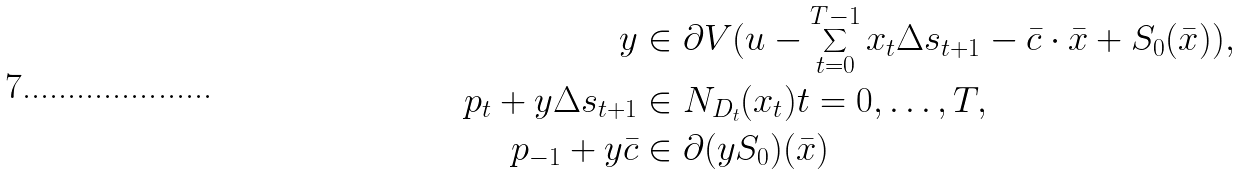<formula> <loc_0><loc_0><loc_500><loc_500>y & \in \partial V ( u - \sum _ { t = 0 } ^ { T - 1 } x _ { t } \Delta s _ { t + 1 } - \bar { c } \cdot \bar { x } + S _ { 0 } ( \bar { x } ) ) , \\ p _ { t } + y \Delta s _ { t + 1 } & \in N _ { D _ { t } } ( x _ { t } ) t = 0 , \dots , T , \\ p _ { - 1 } + y \bar { c } & \in \partial ( y S _ { 0 } ) ( \bar { x } )</formula> 